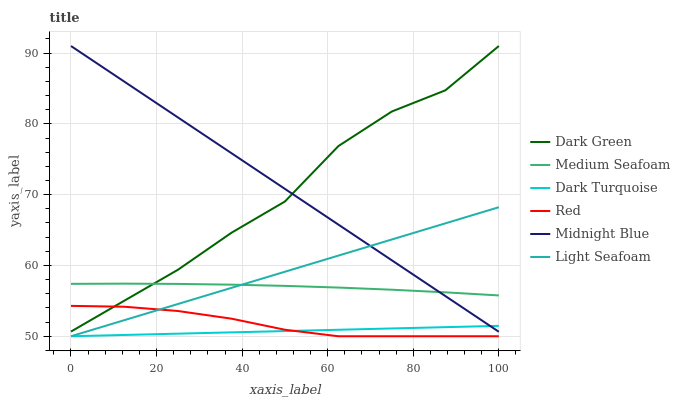Does Dark Turquoise have the minimum area under the curve?
Answer yes or no. Yes. Does Midnight Blue have the maximum area under the curve?
Answer yes or no. Yes. Does Light Seafoam have the minimum area under the curve?
Answer yes or no. No. Does Light Seafoam have the maximum area under the curve?
Answer yes or no. No. Is Light Seafoam the smoothest?
Answer yes or no. Yes. Is Dark Green the roughest?
Answer yes or no. Yes. Is Dark Turquoise the smoothest?
Answer yes or no. No. Is Dark Turquoise the roughest?
Answer yes or no. No. Does Dark Turquoise have the lowest value?
Answer yes or no. Yes. Does Medium Seafoam have the lowest value?
Answer yes or no. No. Does Dark Green have the highest value?
Answer yes or no. Yes. Does Light Seafoam have the highest value?
Answer yes or no. No. Is Dark Turquoise less than Dark Green?
Answer yes or no. Yes. Is Midnight Blue greater than Red?
Answer yes or no. Yes. Does Medium Seafoam intersect Midnight Blue?
Answer yes or no. Yes. Is Medium Seafoam less than Midnight Blue?
Answer yes or no. No. Is Medium Seafoam greater than Midnight Blue?
Answer yes or no. No. Does Dark Turquoise intersect Dark Green?
Answer yes or no. No. 